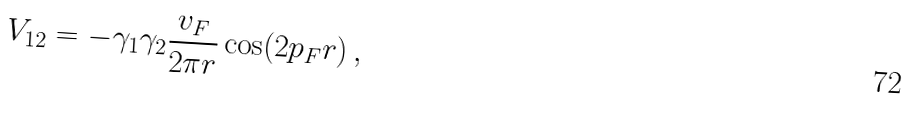<formula> <loc_0><loc_0><loc_500><loc_500>V _ { 1 2 } = - \gamma _ { 1 } \gamma _ { 2 } \frac { v _ { F } } { 2 \pi r } \cos ( 2 p _ { F } r ) \, ,</formula> 